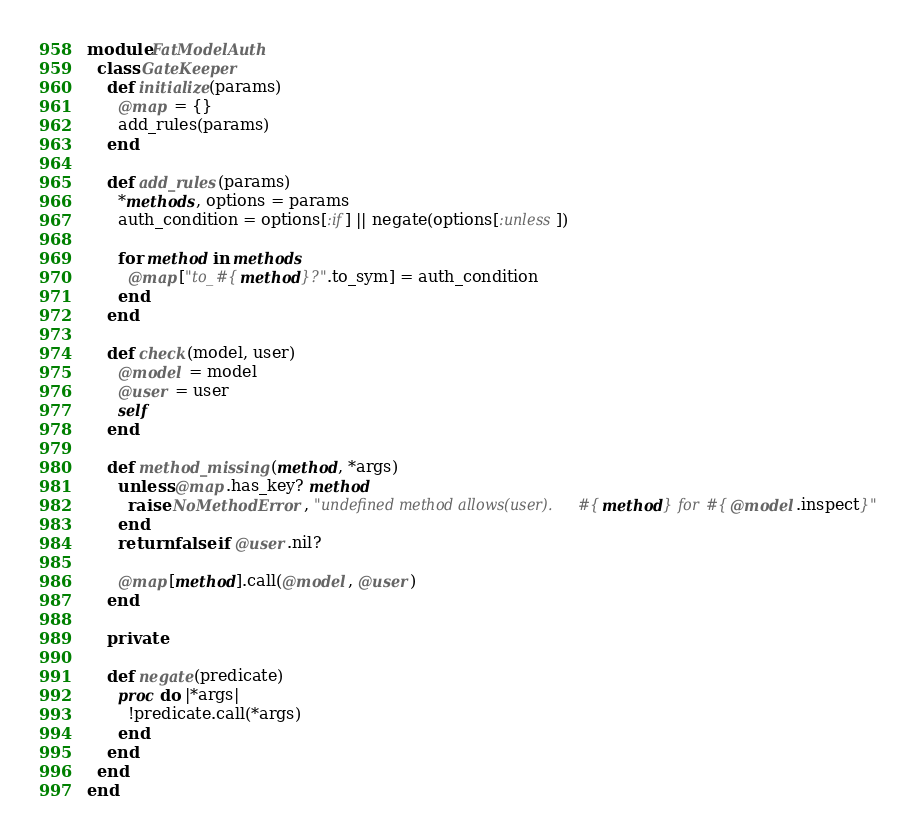<code> <loc_0><loc_0><loc_500><loc_500><_Ruby_>module FatModelAuth
  class GateKeeper
    def initialize(params)
      @map = {}
      add_rules(params)
    end

    def add_rules(params)
      *methods, options = params
      auth_condition = options[:if] || negate(options[:unless])

      for method in methods
        @map["to_#{method}?".to_sym] = auth_condition
      end
    end

    def check(model, user)
      @model = model
      @user = user
      self
    end

    def method_missing(method, *args)
      unless @map.has_key? method
        raise NoMethodError, "undefined method allows(user).#{method} for #{@model.inspect}"
      end
      return false if @user.nil?

      @map[method].call(@model, @user)
    end

    private

    def negate(predicate)
      proc do |*args|
        !predicate.call(*args)
      end
    end
  end
end
</code> 